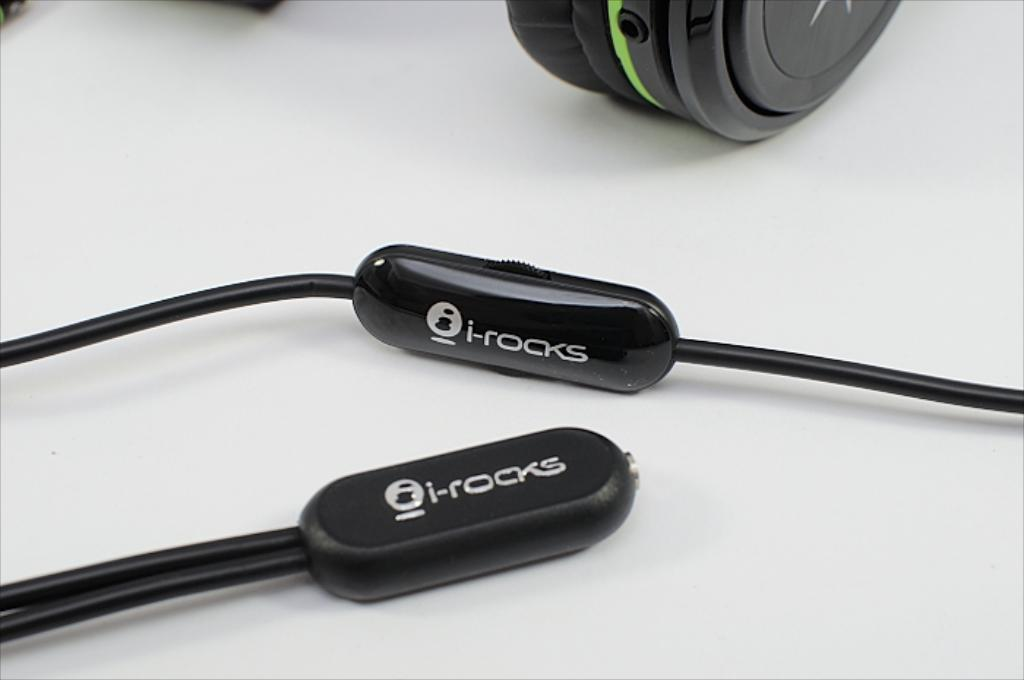<image>
Render a clear and concise summary of the photo. I-rocks wires are on a white surface, in front of a pair of over the ear head phones. 